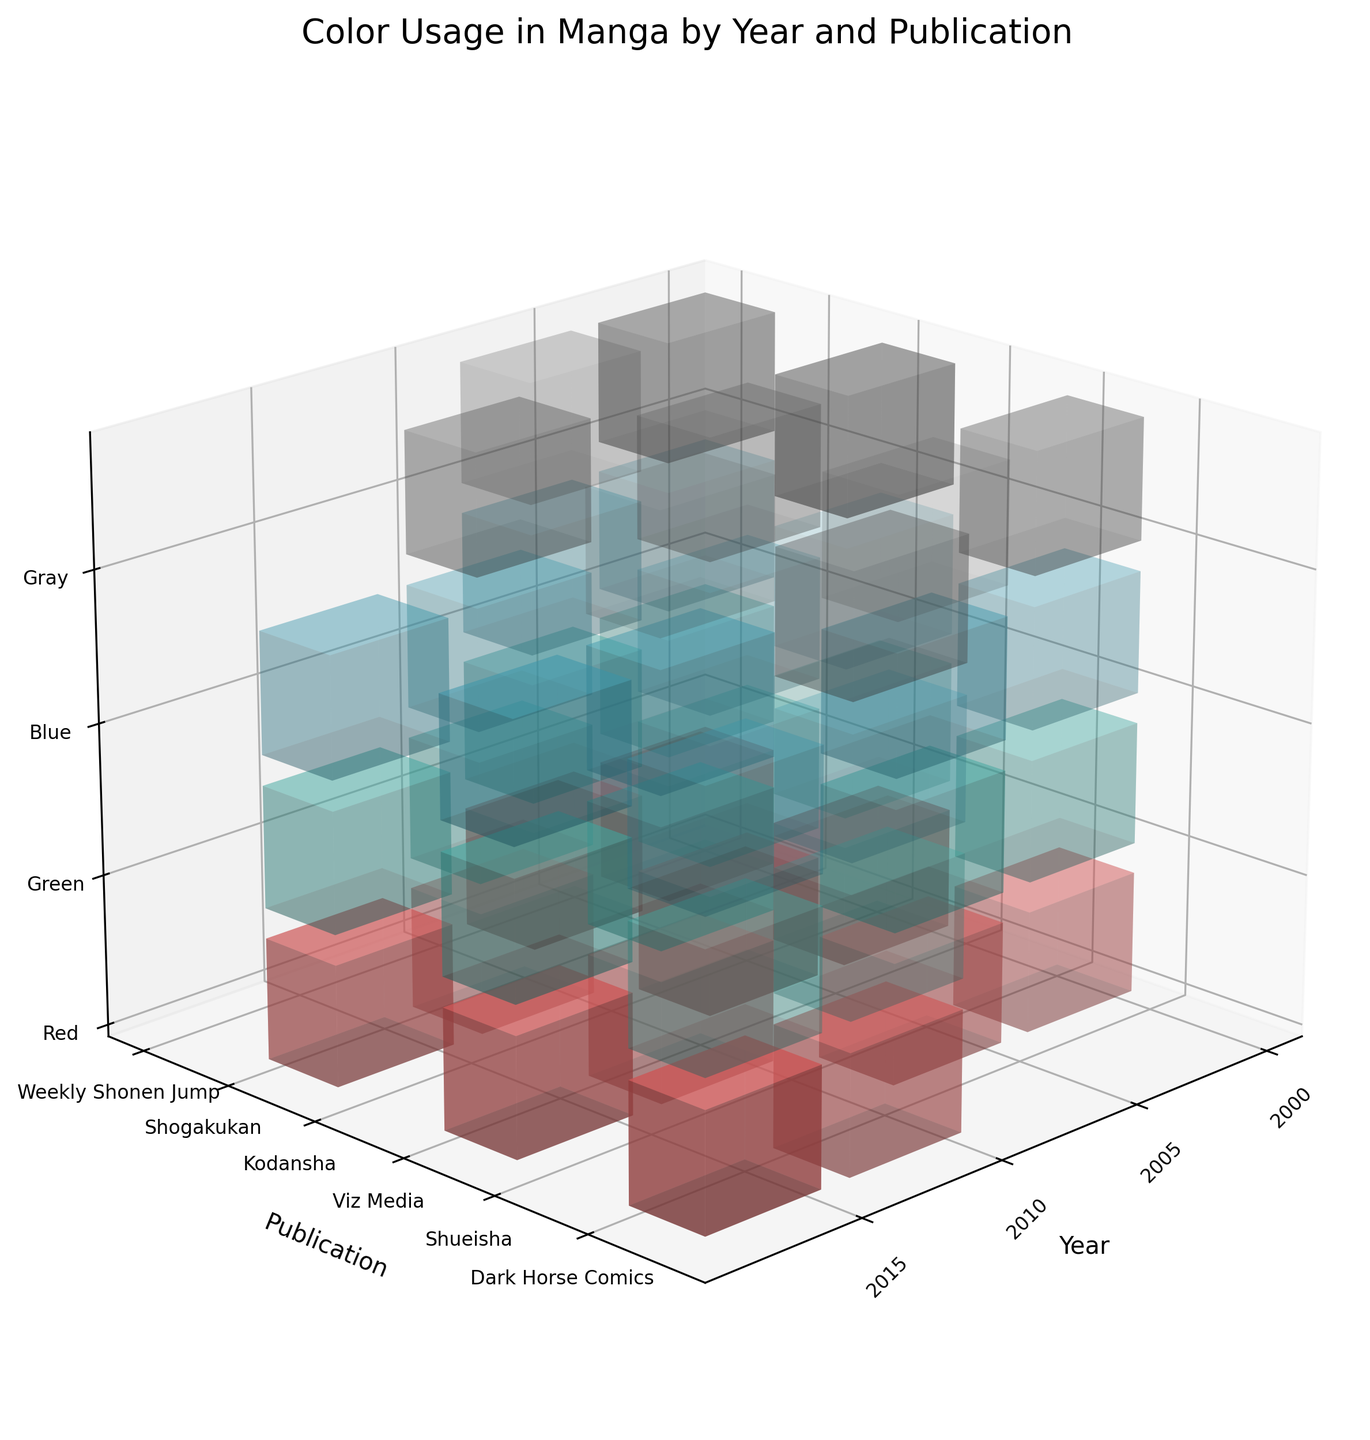What is the title of the figure? The figure's title is located at the top and it provides a brief explanation of what the figure is about.
Answer: Color Usage in Manga by Year and Publication Which color represents "Green" in the figure? The figure includes a color legend; the green color is identified by its distinctive hue.
Answer: #4ECDC4 What are the axes of the 3D plot labeled? The axes labels are located alongside each axis, providing context for the data dimensions.
Answer: X-axis: Year, Y-axis: Publication, Z-axis: Color What color does Dark Horse Comics predominantly use in 2015? By examining the bars corresponding to Dark Horse Comics in 2015, we can see which color has the most significant bar height.
Answer: Red How does the usage of "Gray" change from traditional to digital manga? Compare the height of the "Gray" bars across different years and publishers for both traditional and digital mediums.
Answer: It decreases drastically in digital manga Which year shows the least amount of "Red" usage for Shueisha? Identify the "Red" bar height for Shueisha across all years and determine which is the shortest.
Answer: 2000 Between Weekly Shonen Jump and Kodansha in 2005, which one has a higher usage of "Green"? Compare the heights of the "Green" bars for Weekly Shonen Jump and Kodansha in the year 2005.
Answer: Kodansha What is the total number of publications analyzed in the figure? Count the unique entries along the Publication axis.
Answer: 6 Which publication uses "Blue" the most in 2010? Check the height of the "Blue" bars for each publication in the year 2010 and compare them.
Answer: Viz Media How does the usage of "Gray" in traditional manga compare to its usage in digital manga across all years? Summing up the heights of "Gray" bars for both traditional and digital manga, we can observe a pattern. Traditional manga shows a higher cumulative value of "Gray" bars compared to digital manga.
Answer: Traditional manga uses more "Gray" 